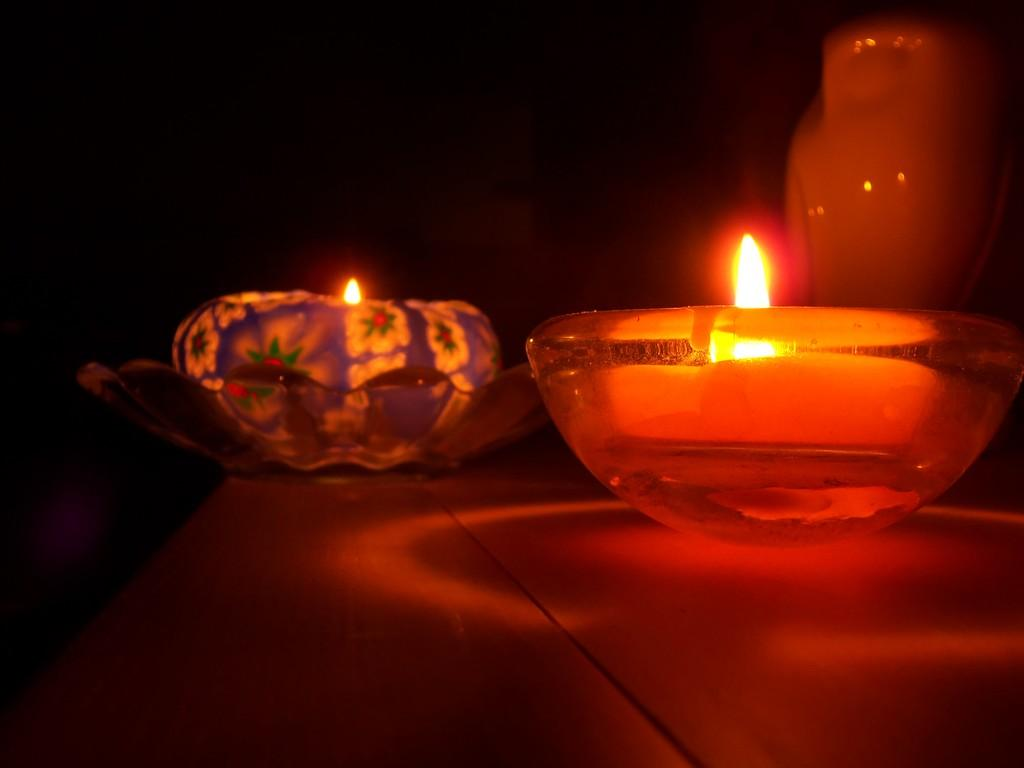What objects can be seen in the image? There are candles in the image. Where are the candles located? The candles are on the surface in the image. Can you describe the position of the candles? The candles are likely in the middle of the image. What can be observed about the background of the image? The background of the image is dark. What type of game is being played in the image? There is no game being played in the image; it features candles on a surface with a dark background. 